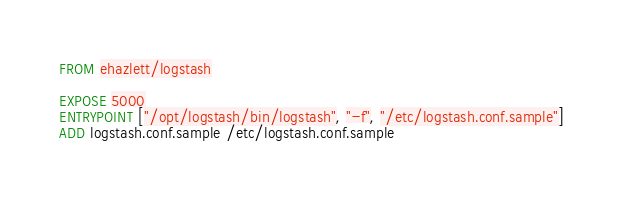<code> <loc_0><loc_0><loc_500><loc_500><_Dockerfile_>FROM ehazlett/logstash

EXPOSE 5000
ENTRYPOINT ["/opt/logstash/bin/logstash", "-f", "/etc/logstash.conf.sample"]
ADD logstash.conf.sample /etc/logstash.conf.sample
</code> 